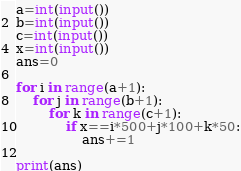Convert code to text. <code><loc_0><loc_0><loc_500><loc_500><_Python_>a=int(input())
b=int(input())
c=int(input())
x=int(input())
ans=0

for i in range(a+1):
    for j in range(b+1):
        for k in range(c+1):
            if x==i*500+j*100+k*50:
                ans+=1

print(ans)</code> 